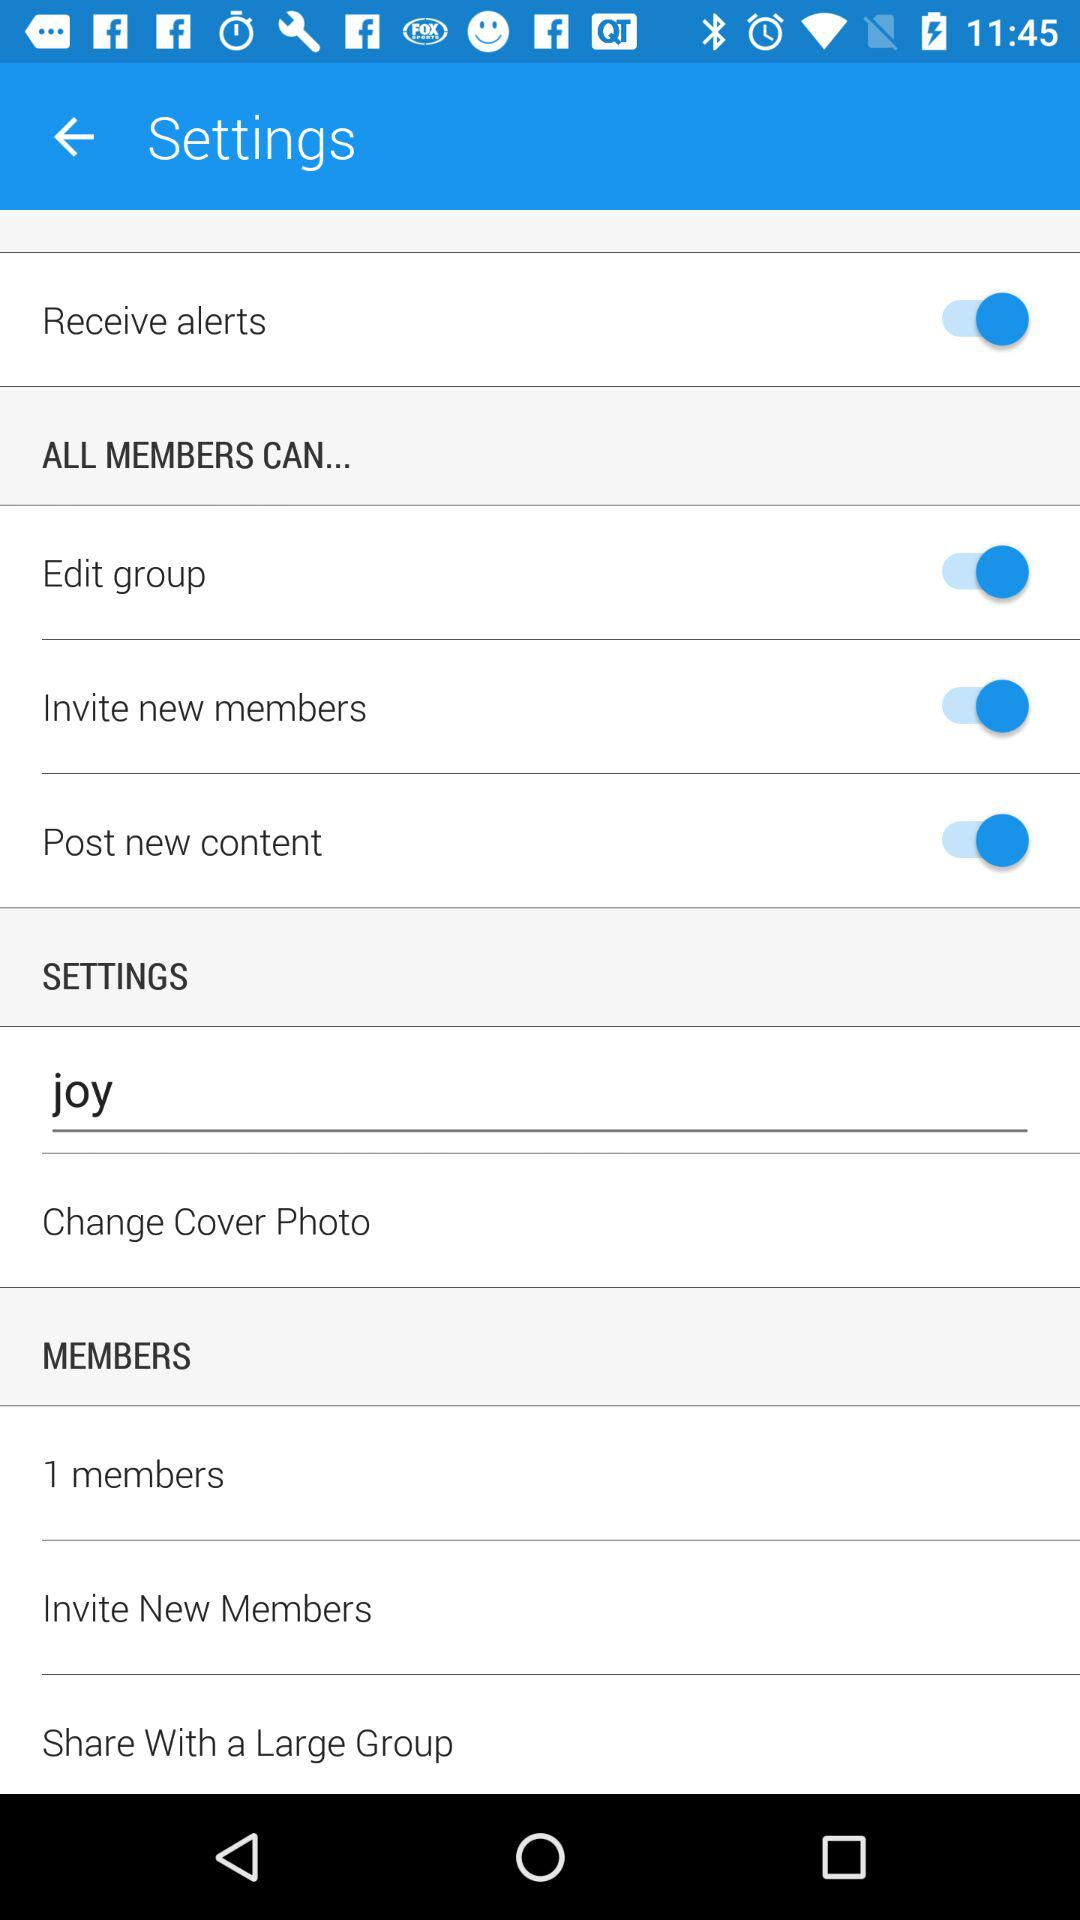How many members are there in this group?
Answer the question using a single word or phrase. 1 